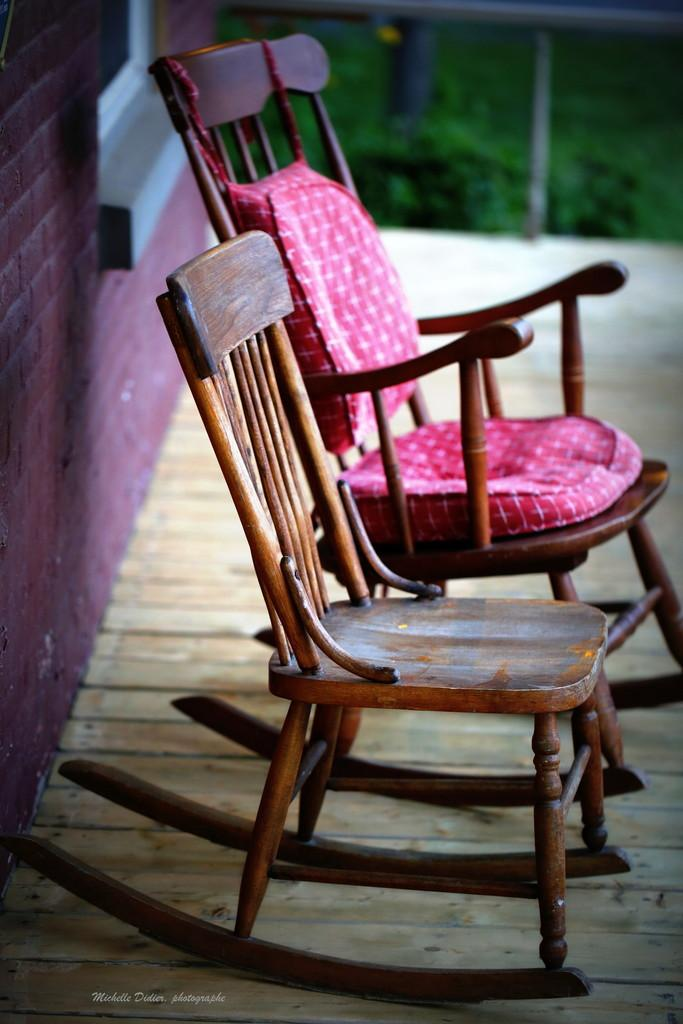What type of furniture is present in the image? There are chairs in the image. Where are the chairs located? The chairs are placed on the floor. What can be seen in the background of the image? There is grass and a wall visible in the background of the image. What type of account is being discussed in the image? There is no account being discussed in the image; it features chairs placed on the floor with a grassy and walled background. 